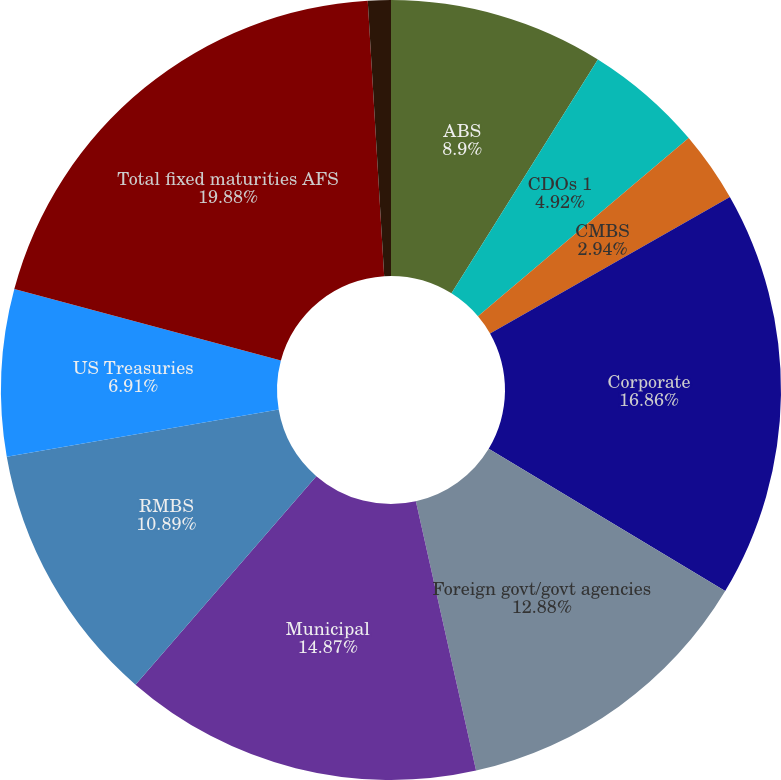Convert chart. <chart><loc_0><loc_0><loc_500><loc_500><pie_chart><fcel>ABS<fcel>CDOs 1<fcel>CMBS<fcel>Corporate<fcel>Foreign govt/govt agencies<fcel>Municipal<fcel>RMBS<fcel>US Treasuries<fcel>Total fixed maturities AFS<fcel>Equity securities AFS<nl><fcel>8.9%<fcel>4.92%<fcel>2.94%<fcel>16.86%<fcel>12.88%<fcel>14.87%<fcel>10.89%<fcel>6.91%<fcel>19.88%<fcel>0.95%<nl></chart> 